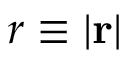Convert formula to latex. <formula><loc_0><loc_0><loc_500><loc_500>r \equiv | r |</formula> 